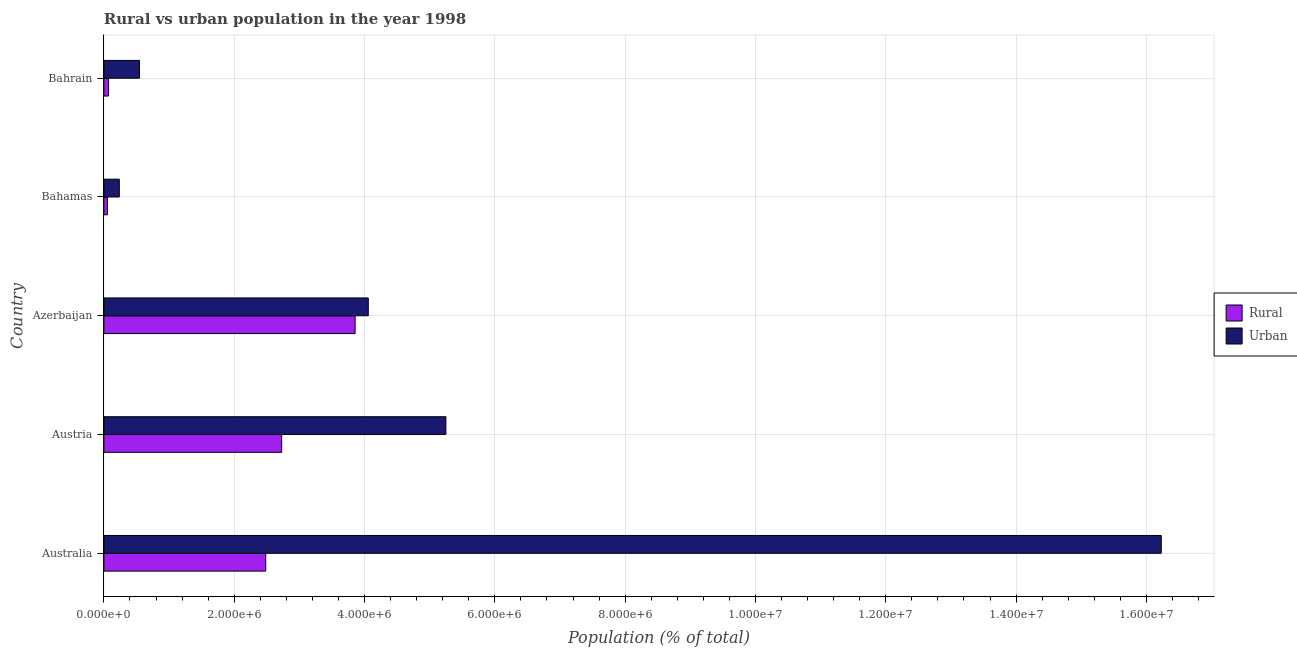Are the number of bars on each tick of the Y-axis equal?
Ensure brevity in your answer.  Yes. What is the label of the 1st group of bars from the top?
Make the answer very short. Bahrain. What is the urban population density in Bahrain?
Ensure brevity in your answer.  5.46e+05. Across all countries, what is the maximum urban population density?
Offer a very short reply. 1.62e+07. Across all countries, what is the minimum urban population density?
Keep it short and to the point. 2.37e+05. In which country was the urban population density minimum?
Provide a succinct answer. Bahamas. What is the total urban population density in the graph?
Provide a succinct answer. 2.63e+07. What is the difference between the rural population density in Australia and that in Bahrain?
Your answer should be compact. 2.41e+06. What is the difference between the urban population density in Australia and the rural population density in Bahrain?
Make the answer very short. 1.62e+07. What is the average urban population density per country?
Offer a terse response. 5.26e+06. What is the difference between the rural population density and urban population density in Austria?
Your answer should be very brief. -2.52e+06. What is the ratio of the urban population density in Bahamas to that in Bahrain?
Ensure brevity in your answer.  0.43. Is the difference between the rural population density in Australia and Bahrain greater than the difference between the urban population density in Australia and Bahrain?
Keep it short and to the point. No. What is the difference between the highest and the second highest rural population density?
Provide a succinct answer. 1.13e+06. What is the difference between the highest and the lowest urban population density?
Ensure brevity in your answer.  1.60e+07. In how many countries, is the urban population density greater than the average urban population density taken over all countries?
Offer a terse response. 1. Is the sum of the urban population density in Bahamas and Bahrain greater than the maximum rural population density across all countries?
Ensure brevity in your answer.  No. What does the 2nd bar from the top in Bahrain represents?
Your answer should be compact. Rural. What does the 2nd bar from the bottom in Bahamas represents?
Your answer should be compact. Urban. How many countries are there in the graph?
Ensure brevity in your answer.  5. What is the difference between two consecutive major ticks on the X-axis?
Your answer should be very brief. 2.00e+06. Are the values on the major ticks of X-axis written in scientific E-notation?
Provide a succinct answer. Yes. How are the legend labels stacked?
Your response must be concise. Vertical. What is the title of the graph?
Your answer should be very brief. Rural vs urban population in the year 1998. Does "Sanitation services" appear as one of the legend labels in the graph?
Your response must be concise. No. What is the label or title of the X-axis?
Make the answer very short. Population (% of total). What is the Population (% of total) in Rural in Australia?
Provide a short and direct response. 2.48e+06. What is the Population (% of total) in Urban in Australia?
Provide a succinct answer. 1.62e+07. What is the Population (% of total) of Rural in Austria?
Your answer should be compact. 2.73e+06. What is the Population (% of total) of Urban in Austria?
Your response must be concise. 5.25e+06. What is the Population (% of total) in Rural in Azerbaijan?
Ensure brevity in your answer.  3.86e+06. What is the Population (% of total) in Urban in Azerbaijan?
Offer a terse response. 4.06e+06. What is the Population (% of total) of Rural in Bahamas?
Give a very brief answer. 5.33e+04. What is the Population (% of total) in Urban in Bahamas?
Your answer should be very brief. 2.37e+05. What is the Population (% of total) of Rural in Bahrain?
Your answer should be very brief. 7.18e+04. What is the Population (% of total) in Urban in Bahrain?
Your response must be concise. 5.46e+05. Across all countries, what is the maximum Population (% of total) in Rural?
Your answer should be compact. 3.86e+06. Across all countries, what is the maximum Population (% of total) in Urban?
Make the answer very short. 1.62e+07. Across all countries, what is the minimum Population (% of total) of Rural?
Provide a succinct answer. 5.33e+04. Across all countries, what is the minimum Population (% of total) in Urban?
Provide a succinct answer. 2.37e+05. What is the total Population (% of total) in Rural in the graph?
Your response must be concise. 9.19e+06. What is the total Population (% of total) of Urban in the graph?
Your answer should be compact. 2.63e+07. What is the difference between the Population (% of total) in Rural in Australia and that in Austria?
Your response must be concise. -2.45e+05. What is the difference between the Population (% of total) in Urban in Australia and that in Austria?
Provide a short and direct response. 1.10e+07. What is the difference between the Population (% of total) of Rural in Australia and that in Azerbaijan?
Provide a succinct answer. -1.37e+06. What is the difference between the Population (% of total) of Urban in Australia and that in Azerbaijan?
Offer a very short reply. 1.22e+07. What is the difference between the Population (% of total) in Rural in Australia and that in Bahamas?
Offer a very short reply. 2.43e+06. What is the difference between the Population (% of total) in Urban in Australia and that in Bahamas?
Provide a succinct answer. 1.60e+07. What is the difference between the Population (% of total) in Rural in Australia and that in Bahrain?
Your response must be concise. 2.41e+06. What is the difference between the Population (% of total) of Urban in Australia and that in Bahrain?
Your answer should be very brief. 1.57e+07. What is the difference between the Population (% of total) of Rural in Austria and that in Azerbaijan?
Keep it short and to the point. -1.13e+06. What is the difference between the Population (% of total) in Urban in Austria and that in Azerbaijan?
Your answer should be compact. 1.19e+06. What is the difference between the Population (% of total) of Rural in Austria and that in Bahamas?
Ensure brevity in your answer.  2.67e+06. What is the difference between the Population (% of total) in Urban in Austria and that in Bahamas?
Your answer should be very brief. 5.01e+06. What is the difference between the Population (% of total) of Rural in Austria and that in Bahrain?
Keep it short and to the point. 2.66e+06. What is the difference between the Population (% of total) in Urban in Austria and that in Bahrain?
Provide a succinct answer. 4.70e+06. What is the difference between the Population (% of total) of Rural in Azerbaijan and that in Bahamas?
Your answer should be compact. 3.80e+06. What is the difference between the Population (% of total) in Urban in Azerbaijan and that in Bahamas?
Ensure brevity in your answer.  3.82e+06. What is the difference between the Population (% of total) of Rural in Azerbaijan and that in Bahrain?
Keep it short and to the point. 3.78e+06. What is the difference between the Population (% of total) of Urban in Azerbaijan and that in Bahrain?
Offer a very short reply. 3.51e+06. What is the difference between the Population (% of total) of Rural in Bahamas and that in Bahrain?
Ensure brevity in your answer.  -1.85e+04. What is the difference between the Population (% of total) of Urban in Bahamas and that in Bahrain?
Give a very brief answer. -3.10e+05. What is the difference between the Population (% of total) of Rural in Australia and the Population (% of total) of Urban in Austria?
Provide a short and direct response. -2.77e+06. What is the difference between the Population (% of total) in Rural in Australia and the Population (% of total) in Urban in Azerbaijan?
Provide a short and direct response. -1.57e+06. What is the difference between the Population (% of total) of Rural in Australia and the Population (% of total) of Urban in Bahamas?
Offer a very short reply. 2.25e+06. What is the difference between the Population (% of total) of Rural in Australia and the Population (% of total) of Urban in Bahrain?
Your answer should be very brief. 1.94e+06. What is the difference between the Population (% of total) of Rural in Austria and the Population (% of total) of Urban in Azerbaijan?
Your answer should be very brief. -1.33e+06. What is the difference between the Population (% of total) of Rural in Austria and the Population (% of total) of Urban in Bahamas?
Give a very brief answer. 2.49e+06. What is the difference between the Population (% of total) in Rural in Austria and the Population (% of total) in Urban in Bahrain?
Your answer should be compact. 2.18e+06. What is the difference between the Population (% of total) of Rural in Azerbaijan and the Population (% of total) of Urban in Bahamas?
Make the answer very short. 3.62e+06. What is the difference between the Population (% of total) in Rural in Azerbaijan and the Population (% of total) in Urban in Bahrain?
Ensure brevity in your answer.  3.31e+06. What is the difference between the Population (% of total) in Rural in Bahamas and the Population (% of total) in Urban in Bahrain?
Offer a very short reply. -4.93e+05. What is the average Population (% of total) of Rural per country?
Make the answer very short. 1.84e+06. What is the average Population (% of total) in Urban per country?
Your answer should be very brief. 5.26e+06. What is the difference between the Population (% of total) in Rural and Population (% of total) in Urban in Australia?
Provide a short and direct response. -1.37e+07. What is the difference between the Population (% of total) of Rural and Population (% of total) of Urban in Austria?
Make the answer very short. -2.52e+06. What is the difference between the Population (% of total) in Rural and Population (% of total) in Urban in Azerbaijan?
Offer a very short reply. -2.02e+05. What is the difference between the Population (% of total) of Rural and Population (% of total) of Urban in Bahamas?
Provide a succinct answer. -1.83e+05. What is the difference between the Population (% of total) of Rural and Population (% of total) of Urban in Bahrain?
Keep it short and to the point. -4.74e+05. What is the ratio of the Population (% of total) of Rural in Australia to that in Austria?
Offer a very short reply. 0.91. What is the ratio of the Population (% of total) of Urban in Australia to that in Austria?
Keep it short and to the point. 3.09. What is the ratio of the Population (% of total) of Rural in Australia to that in Azerbaijan?
Your response must be concise. 0.64. What is the ratio of the Population (% of total) in Urban in Australia to that in Azerbaijan?
Provide a succinct answer. 4. What is the ratio of the Population (% of total) of Rural in Australia to that in Bahamas?
Provide a succinct answer. 46.56. What is the ratio of the Population (% of total) in Urban in Australia to that in Bahamas?
Your response must be concise. 68.55. What is the ratio of the Population (% of total) in Rural in Australia to that in Bahrain?
Your answer should be very brief. 34.58. What is the ratio of the Population (% of total) of Urban in Australia to that in Bahrain?
Keep it short and to the point. 29.71. What is the ratio of the Population (% of total) of Rural in Austria to that in Azerbaijan?
Offer a terse response. 0.71. What is the ratio of the Population (% of total) in Urban in Austria to that in Azerbaijan?
Keep it short and to the point. 1.29. What is the ratio of the Population (% of total) in Rural in Austria to that in Bahamas?
Give a very brief answer. 51.15. What is the ratio of the Population (% of total) of Urban in Austria to that in Bahamas?
Make the answer very short. 22.17. What is the ratio of the Population (% of total) of Rural in Austria to that in Bahrain?
Offer a very short reply. 37.98. What is the ratio of the Population (% of total) of Urban in Austria to that in Bahrain?
Provide a short and direct response. 9.61. What is the ratio of the Population (% of total) in Rural in Azerbaijan to that in Bahamas?
Provide a succinct answer. 72.28. What is the ratio of the Population (% of total) in Urban in Azerbaijan to that in Bahamas?
Provide a short and direct response. 17.14. What is the ratio of the Population (% of total) of Rural in Azerbaijan to that in Bahrain?
Provide a short and direct response. 53.68. What is the ratio of the Population (% of total) in Urban in Azerbaijan to that in Bahrain?
Ensure brevity in your answer.  7.43. What is the ratio of the Population (% of total) of Rural in Bahamas to that in Bahrain?
Provide a short and direct response. 0.74. What is the ratio of the Population (% of total) of Urban in Bahamas to that in Bahrain?
Provide a succinct answer. 0.43. What is the difference between the highest and the second highest Population (% of total) in Rural?
Provide a short and direct response. 1.13e+06. What is the difference between the highest and the second highest Population (% of total) in Urban?
Your response must be concise. 1.10e+07. What is the difference between the highest and the lowest Population (% of total) of Rural?
Keep it short and to the point. 3.80e+06. What is the difference between the highest and the lowest Population (% of total) of Urban?
Offer a very short reply. 1.60e+07. 